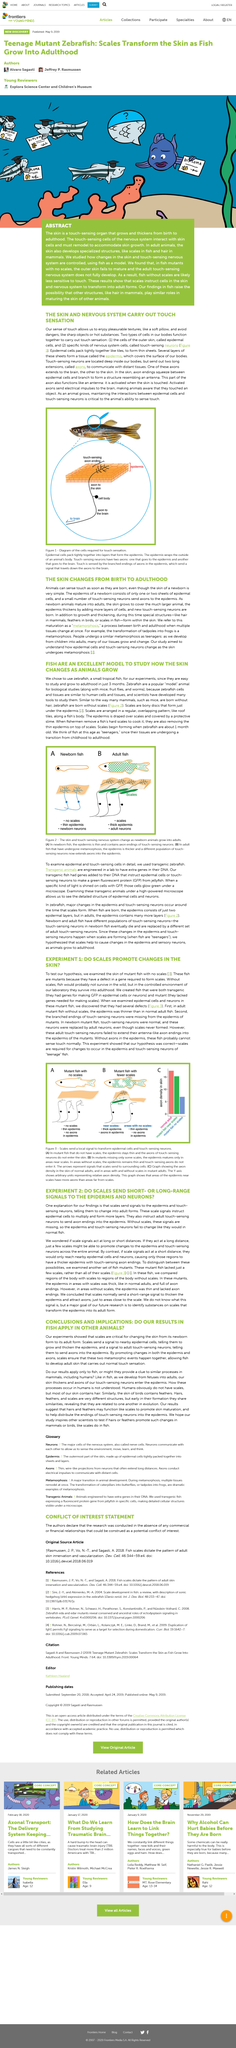List a handful of essential elements in this visual. The epidermis of a newborn consists of one or two sheets of epidermal cells, along with a small number of touch-sensing neurons that send axons to the epidermis. The epidermal cells and touch-sensing neurons are responsible for transmitting touch sensations to the brain. Newborn zebrafish are born without scales, a characteristic that distinguishes them from adult zebrafish. Zebrafish typically mature into adulthood within a period of three months. A metamorphosis is a process that occurs between birth and adulthood, during which multiple tissues undergo significant transformations at the same time. 